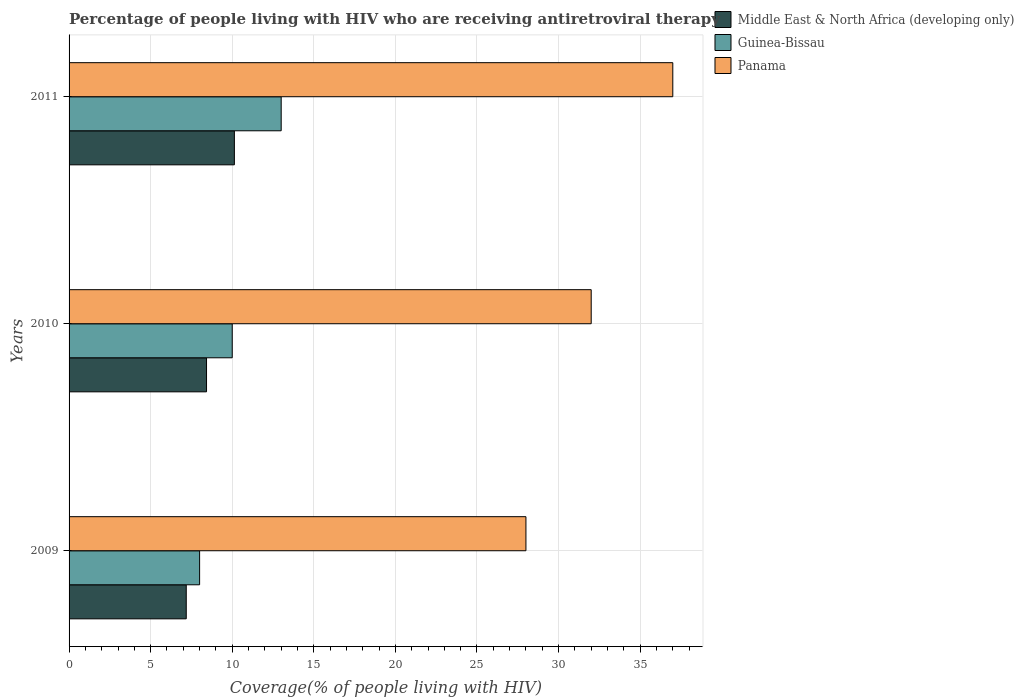How many different coloured bars are there?
Offer a terse response. 3. How many groups of bars are there?
Provide a short and direct response. 3. Are the number of bars per tick equal to the number of legend labels?
Keep it short and to the point. Yes. Are the number of bars on each tick of the Y-axis equal?
Ensure brevity in your answer.  Yes. What is the label of the 3rd group of bars from the top?
Ensure brevity in your answer.  2009. What is the percentage of the HIV infected people who are receiving antiretroviral therapy in Panama in 2009?
Provide a short and direct response. 28. Across all years, what is the maximum percentage of the HIV infected people who are receiving antiretroviral therapy in Middle East & North Africa (developing only)?
Your answer should be very brief. 10.13. Across all years, what is the minimum percentage of the HIV infected people who are receiving antiretroviral therapy in Panama?
Your answer should be very brief. 28. In which year was the percentage of the HIV infected people who are receiving antiretroviral therapy in Panama maximum?
Make the answer very short. 2011. In which year was the percentage of the HIV infected people who are receiving antiretroviral therapy in Middle East & North Africa (developing only) minimum?
Ensure brevity in your answer.  2009. What is the total percentage of the HIV infected people who are receiving antiretroviral therapy in Panama in the graph?
Provide a short and direct response. 97. What is the difference between the percentage of the HIV infected people who are receiving antiretroviral therapy in Middle East & North Africa (developing only) in 2009 and that in 2011?
Ensure brevity in your answer.  -2.95. What is the difference between the percentage of the HIV infected people who are receiving antiretroviral therapy in Middle East & North Africa (developing only) in 2010 and the percentage of the HIV infected people who are receiving antiretroviral therapy in Panama in 2009?
Your response must be concise. -19.58. What is the average percentage of the HIV infected people who are receiving antiretroviral therapy in Panama per year?
Offer a terse response. 32.33. In the year 2011, what is the difference between the percentage of the HIV infected people who are receiving antiretroviral therapy in Middle East & North Africa (developing only) and percentage of the HIV infected people who are receiving antiretroviral therapy in Panama?
Offer a terse response. -26.87. Is the percentage of the HIV infected people who are receiving antiretroviral therapy in Guinea-Bissau in 2010 less than that in 2011?
Provide a succinct answer. Yes. Is the difference between the percentage of the HIV infected people who are receiving antiretroviral therapy in Middle East & North Africa (developing only) in 2009 and 2011 greater than the difference between the percentage of the HIV infected people who are receiving antiretroviral therapy in Panama in 2009 and 2011?
Give a very brief answer. Yes. What is the difference between the highest and the second highest percentage of the HIV infected people who are receiving antiretroviral therapy in Middle East & North Africa (developing only)?
Keep it short and to the point. 1.71. What is the difference between the highest and the lowest percentage of the HIV infected people who are receiving antiretroviral therapy in Middle East & North Africa (developing only)?
Keep it short and to the point. 2.95. What does the 2nd bar from the top in 2011 represents?
Make the answer very short. Guinea-Bissau. What does the 2nd bar from the bottom in 2009 represents?
Offer a very short reply. Guinea-Bissau. Are all the bars in the graph horizontal?
Keep it short and to the point. Yes. How many years are there in the graph?
Your answer should be very brief. 3. What is the difference between two consecutive major ticks on the X-axis?
Offer a terse response. 5. Does the graph contain any zero values?
Provide a short and direct response. No. What is the title of the graph?
Ensure brevity in your answer.  Percentage of people living with HIV who are receiving antiretroviral therapy. What is the label or title of the X-axis?
Give a very brief answer. Coverage(% of people living with HIV). What is the Coverage(% of people living with HIV) of Middle East & North Africa (developing only) in 2009?
Give a very brief answer. 7.18. What is the Coverage(% of people living with HIV) of Middle East & North Africa (developing only) in 2010?
Offer a terse response. 8.42. What is the Coverage(% of people living with HIV) of Guinea-Bissau in 2010?
Your response must be concise. 10. What is the Coverage(% of people living with HIV) in Panama in 2010?
Provide a short and direct response. 32. What is the Coverage(% of people living with HIV) of Middle East & North Africa (developing only) in 2011?
Provide a succinct answer. 10.13. What is the Coverage(% of people living with HIV) of Guinea-Bissau in 2011?
Make the answer very short. 13. What is the Coverage(% of people living with HIV) in Panama in 2011?
Your response must be concise. 37. Across all years, what is the maximum Coverage(% of people living with HIV) in Middle East & North Africa (developing only)?
Your response must be concise. 10.13. Across all years, what is the maximum Coverage(% of people living with HIV) in Guinea-Bissau?
Provide a short and direct response. 13. Across all years, what is the minimum Coverage(% of people living with HIV) of Middle East & North Africa (developing only)?
Ensure brevity in your answer.  7.18. Across all years, what is the minimum Coverage(% of people living with HIV) in Guinea-Bissau?
Provide a succinct answer. 8. What is the total Coverage(% of people living with HIV) of Middle East & North Africa (developing only) in the graph?
Give a very brief answer. 25.74. What is the total Coverage(% of people living with HIV) of Guinea-Bissau in the graph?
Your answer should be compact. 31. What is the total Coverage(% of people living with HIV) in Panama in the graph?
Keep it short and to the point. 97. What is the difference between the Coverage(% of people living with HIV) in Middle East & North Africa (developing only) in 2009 and that in 2010?
Offer a terse response. -1.24. What is the difference between the Coverage(% of people living with HIV) in Middle East & North Africa (developing only) in 2009 and that in 2011?
Provide a short and direct response. -2.95. What is the difference between the Coverage(% of people living with HIV) in Panama in 2009 and that in 2011?
Offer a very short reply. -9. What is the difference between the Coverage(% of people living with HIV) of Middle East & North Africa (developing only) in 2010 and that in 2011?
Ensure brevity in your answer.  -1.71. What is the difference between the Coverage(% of people living with HIV) of Guinea-Bissau in 2010 and that in 2011?
Offer a terse response. -3. What is the difference between the Coverage(% of people living with HIV) in Panama in 2010 and that in 2011?
Provide a succinct answer. -5. What is the difference between the Coverage(% of people living with HIV) of Middle East & North Africa (developing only) in 2009 and the Coverage(% of people living with HIV) of Guinea-Bissau in 2010?
Give a very brief answer. -2.82. What is the difference between the Coverage(% of people living with HIV) in Middle East & North Africa (developing only) in 2009 and the Coverage(% of people living with HIV) in Panama in 2010?
Your answer should be very brief. -24.82. What is the difference between the Coverage(% of people living with HIV) of Middle East & North Africa (developing only) in 2009 and the Coverage(% of people living with HIV) of Guinea-Bissau in 2011?
Give a very brief answer. -5.82. What is the difference between the Coverage(% of people living with HIV) in Middle East & North Africa (developing only) in 2009 and the Coverage(% of people living with HIV) in Panama in 2011?
Your answer should be very brief. -29.82. What is the difference between the Coverage(% of people living with HIV) of Middle East & North Africa (developing only) in 2010 and the Coverage(% of people living with HIV) of Guinea-Bissau in 2011?
Keep it short and to the point. -4.58. What is the difference between the Coverage(% of people living with HIV) in Middle East & North Africa (developing only) in 2010 and the Coverage(% of people living with HIV) in Panama in 2011?
Your response must be concise. -28.58. What is the difference between the Coverage(% of people living with HIV) of Guinea-Bissau in 2010 and the Coverage(% of people living with HIV) of Panama in 2011?
Offer a terse response. -27. What is the average Coverage(% of people living with HIV) in Middle East & North Africa (developing only) per year?
Offer a terse response. 8.58. What is the average Coverage(% of people living with HIV) in Guinea-Bissau per year?
Ensure brevity in your answer.  10.33. What is the average Coverage(% of people living with HIV) in Panama per year?
Your answer should be very brief. 32.33. In the year 2009, what is the difference between the Coverage(% of people living with HIV) in Middle East & North Africa (developing only) and Coverage(% of people living with HIV) in Guinea-Bissau?
Give a very brief answer. -0.82. In the year 2009, what is the difference between the Coverage(% of people living with HIV) of Middle East & North Africa (developing only) and Coverage(% of people living with HIV) of Panama?
Provide a succinct answer. -20.82. In the year 2010, what is the difference between the Coverage(% of people living with HIV) of Middle East & North Africa (developing only) and Coverage(% of people living with HIV) of Guinea-Bissau?
Your answer should be very brief. -1.58. In the year 2010, what is the difference between the Coverage(% of people living with HIV) in Middle East & North Africa (developing only) and Coverage(% of people living with HIV) in Panama?
Provide a succinct answer. -23.58. In the year 2011, what is the difference between the Coverage(% of people living with HIV) of Middle East & North Africa (developing only) and Coverage(% of people living with HIV) of Guinea-Bissau?
Ensure brevity in your answer.  -2.87. In the year 2011, what is the difference between the Coverage(% of people living with HIV) in Middle East & North Africa (developing only) and Coverage(% of people living with HIV) in Panama?
Provide a succinct answer. -26.87. What is the ratio of the Coverage(% of people living with HIV) of Middle East & North Africa (developing only) in 2009 to that in 2010?
Your answer should be very brief. 0.85. What is the ratio of the Coverage(% of people living with HIV) of Panama in 2009 to that in 2010?
Your answer should be very brief. 0.88. What is the ratio of the Coverage(% of people living with HIV) of Middle East & North Africa (developing only) in 2009 to that in 2011?
Ensure brevity in your answer.  0.71. What is the ratio of the Coverage(% of people living with HIV) in Guinea-Bissau in 2009 to that in 2011?
Offer a terse response. 0.62. What is the ratio of the Coverage(% of people living with HIV) of Panama in 2009 to that in 2011?
Your response must be concise. 0.76. What is the ratio of the Coverage(% of people living with HIV) of Middle East & North Africa (developing only) in 2010 to that in 2011?
Make the answer very short. 0.83. What is the ratio of the Coverage(% of people living with HIV) in Guinea-Bissau in 2010 to that in 2011?
Your answer should be very brief. 0.77. What is the ratio of the Coverage(% of people living with HIV) of Panama in 2010 to that in 2011?
Offer a terse response. 0.86. What is the difference between the highest and the second highest Coverage(% of people living with HIV) of Middle East & North Africa (developing only)?
Ensure brevity in your answer.  1.71. What is the difference between the highest and the second highest Coverage(% of people living with HIV) in Guinea-Bissau?
Your answer should be very brief. 3. What is the difference between the highest and the second highest Coverage(% of people living with HIV) in Panama?
Your answer should be compact. 5. What is the difference between the highest and the lowest Coverage(% of people living with HIV) in Middle East & North Africa (developing only)?
Your answer should be very brief. 2.95. What is the difference between the highest and the lowest Coverage(% of people living with HIV) in Guinea-Bissau?
Provide a succinct answer. 5. What is the difference between the highest and the lowest Coverage(% of people living with HIV) of Panama?
Ensure brevity in your answer.  9. 